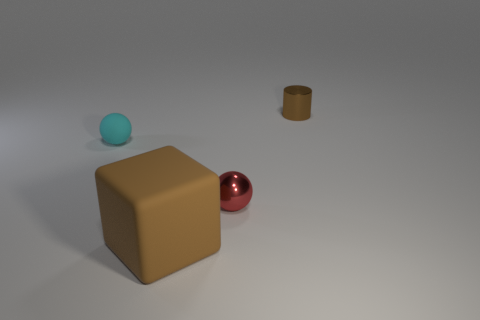Is the color of the large thing that is in front of the metal cylinder the same as the small object that is behind the small matte thing?
Make the answer very short. Yes. There is a object that is both on the right side of the large matte thing and in front of the small cyan rubber object; what is its color?
Keep it short and to the point. Red. How many other objects are there of the same shape as the cyan rubber object?
Make the answer very short. 1. The shiny object that is the same size as the brown cylinder is what color?
Ensure brevity in your answer.  Red. What color is the sphere in front of the cyan sphere?
Ensure brevity in your answer.  Red. Is there a small cyan object that is behind the matte object in front of the tiny metal sphere?
Your answer should be compact. Yes. There is a cyan matte thing; does it have the same shape as the small thing that is in front of the cyan thing?
Provide a short and direct response. Yes. What size is the object that is in front of the cyan object and on the left side of the tiny red shiny ball?
Offer a very short reply. Large. Are there any cylinders made of the same material as the tiny red sphere?
Give a very brief answer. Yes. There is a rubber thing that is the same color as the metal cylinder; what size is it?
Offer a terse response. Large. 